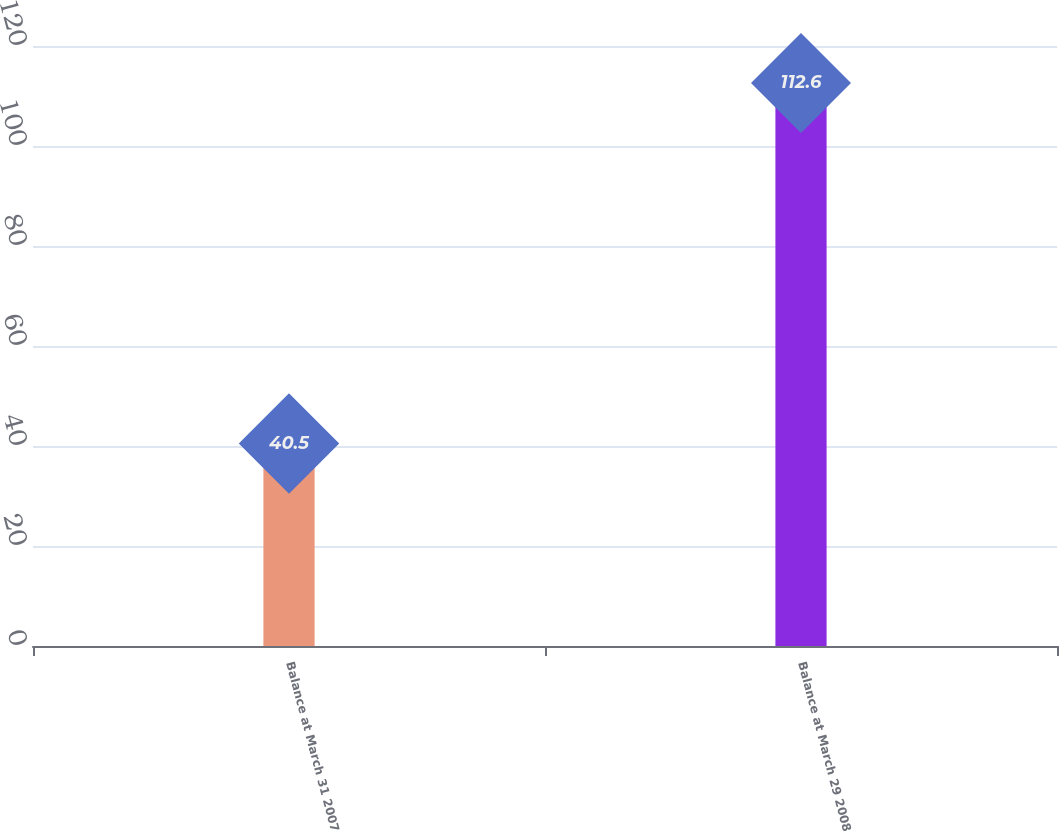Convert chart to OTSL. <chart><loc_0><loc_0><loc_500><loc_500><bar_chart><fcel>Balance at March 31 2007<fcel>Balance at March 29 2008<nl><fcel>40.5<fcel>112.6<nl></chart> 